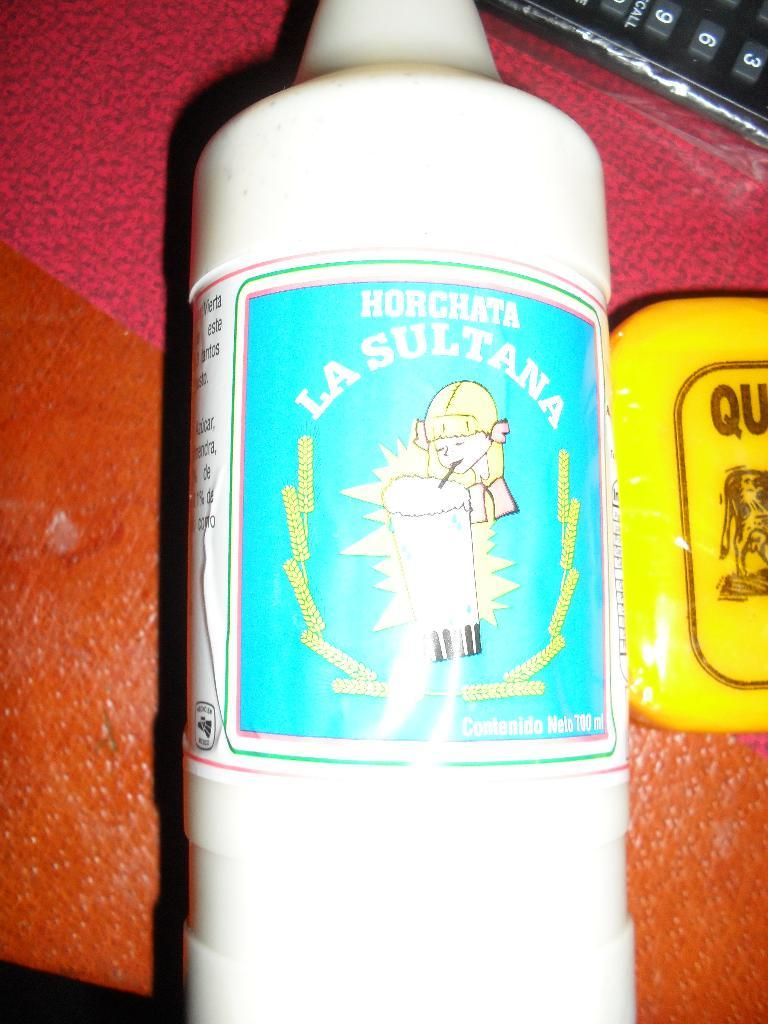Provide a one-sentence caption for the provided image. a bottle that has a label that says 'horchata la sultana'. 